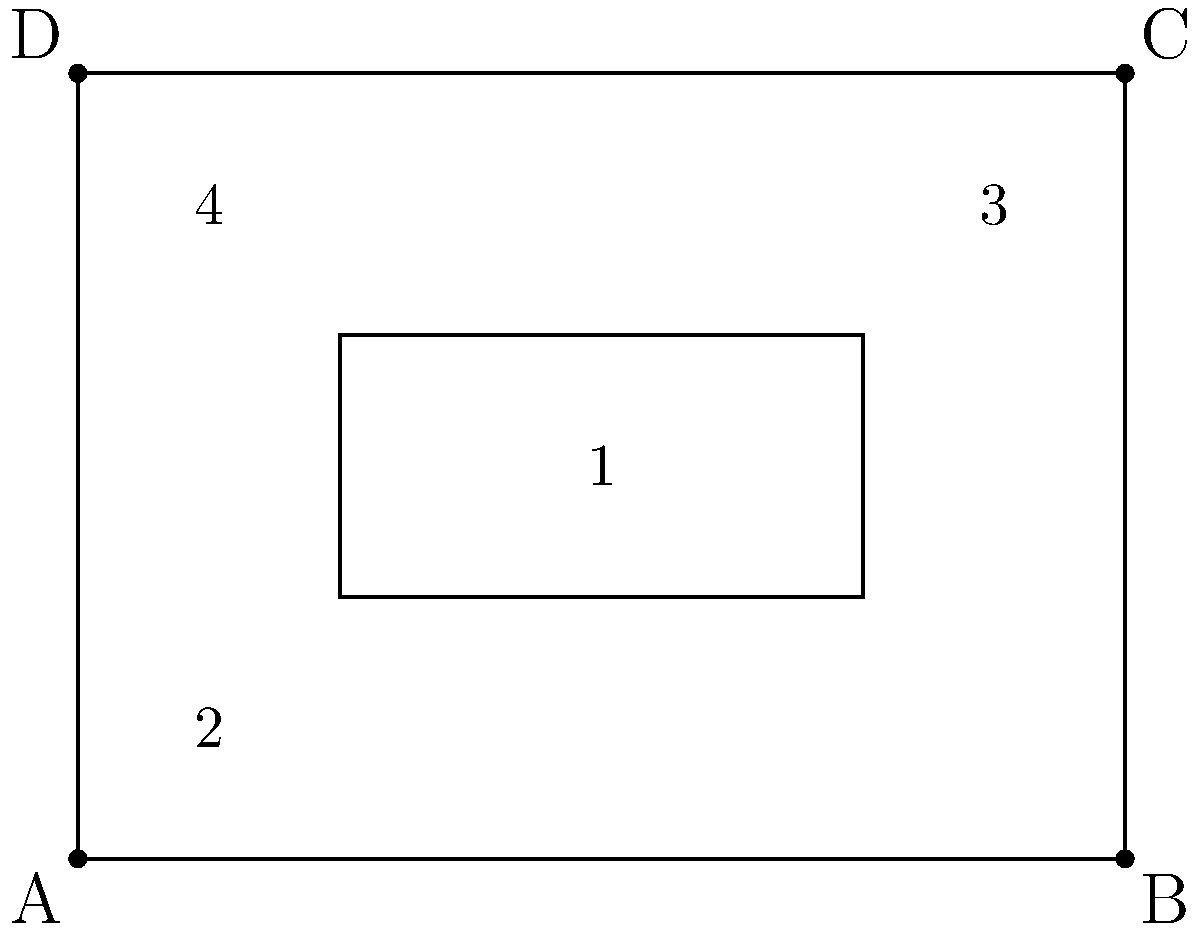In film cinematography, camera angles are often represented using geometric shapes. The outer rectangle ABCD represents a wide-angle shot of a scene, while the inner rectangle represents a close-up shot. Which numbered area in the diagram would best represent a camera angle similar to the close-up shot but positioned in the top-left corner of the frame? To answer this question, we need to analyze the geometric representation of camera angles in the given diagram:

1. The outer rectangle ABCD represents a wide-angle shot of the entire scene.
2. The inner rectangle (labeled as area 1) represents a close-up shot, positioned in the center of the frame.
3. We are asked to find an area that represents a similar camera angle to the close-up shot but positioned in the top-left corner of the frame.

Let's examine each numbered area:

1. Area 1 is the given close-up shot, centered in the frame.
2. Area 2 is in the bottom-left corner, which doesn't match the required position.
3. Area 3 is in the top-right corner, which is not the correct position.
4. Area 4 is in the top-left corner of the frame.

Area 4 is the only option that meets both criteria:
a) It has a similar size and shape to the close-up shot (area 1), representing a similar camera angle.
b) It is positioned in the top-left corner of the frame, as required by the question.

Therefore, area 4 best represents a camera angle similar to the close-up shot but positioned in the top-left corner of the frame.
Answer: 4 